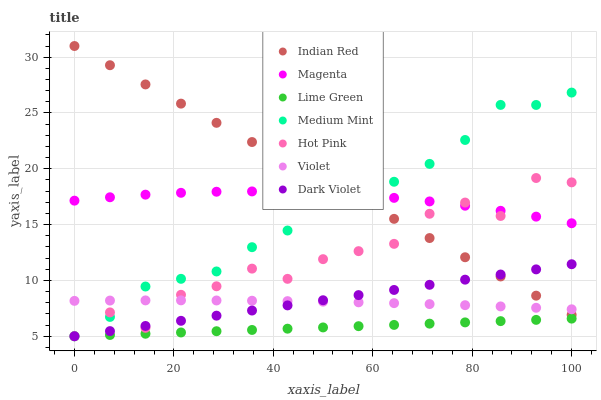Does Lime Green have the minimum area under the curve?
Answer yes or no. Yes. Does Indian Red have the maximum area under the curve?
Answer yes or no. Yes. Does Hot Pink have the minimum area under the curve?
Answer yes or no. No. Does Hot Pink have the maximum area under the curve?
Answer yes or no. No. Is Lime Green the smoothest?
Answer yes or no. Yes. Is Hot Pink the roughest?
Answer yes or no. Yes. Is Dark Violet the smoothest?
Answer yes or no. No. Is Dark Violet the roughest?
Answer yes or no. No. Does Medium Mint have the lowest value?
Answer yes or no. Yes. Does Indian Red have the lowest value?
Answer yes or no. No. Does Indian Red have the highest value?
Answer yes or no. Yes. Does Hot Pink have the highest value?
Answer yes or no. No. Is Lime Green less than Indian Red?
Answer yes or no. Yes. Is Magenta greater than Lime Green?
Answer yes or no. Yes. Does Hot Pink intersect Violet?
Answer yes or no. Yes. Is Hot Pink less than Violet?
Answer yes or no. No. Is Hot Pink greater than Violet?
Answer yes or no. No. Does Lime Green intersect Indian Red?
Answer yes or no. No. 